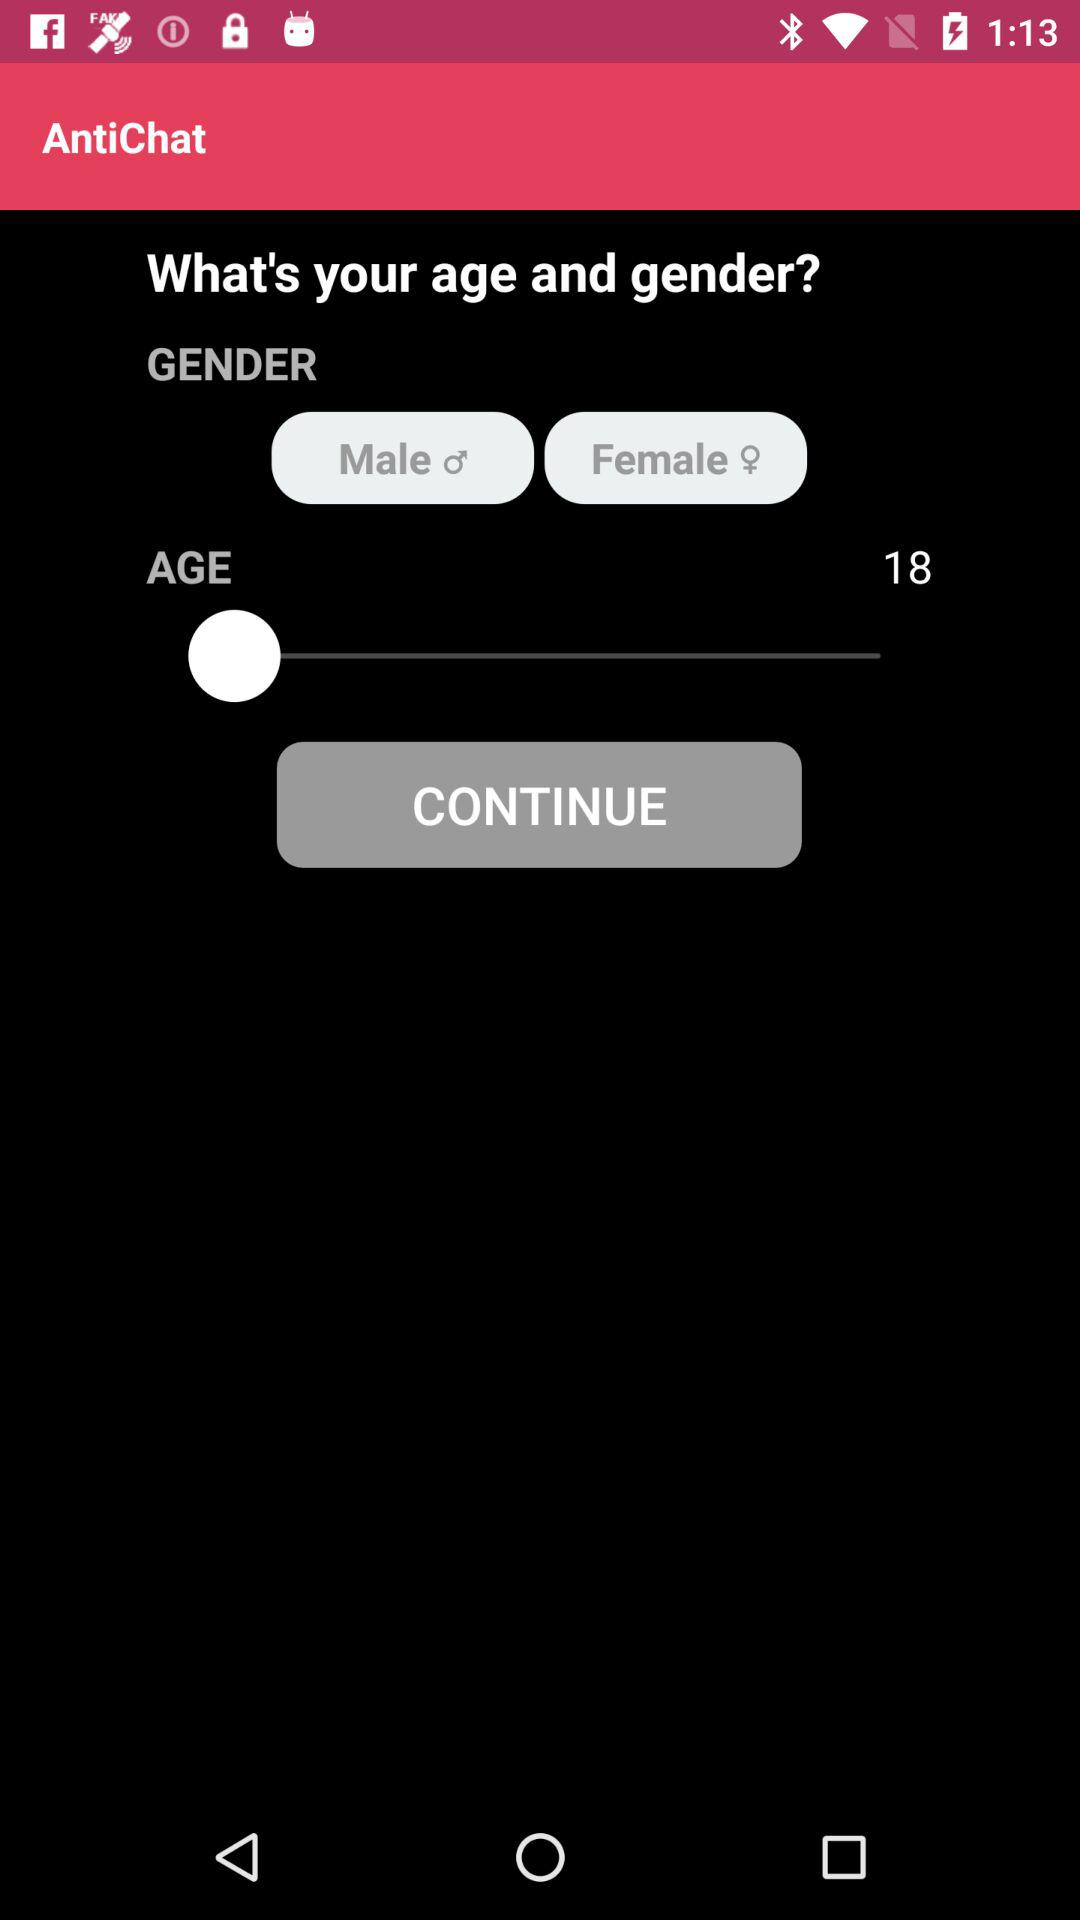What is maximum age allow?
When the provided information is insufficient, respond with <no answer>. <no answer> 